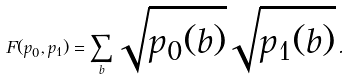Convert formula to latex. <formula><loc_0><loc_0><loc_500><loc_500>F ( p _ { 0 } , p _ { 1 } ) = \sum _ { b } \sqrt { p _ { 0 } ( b ) } \sqrt { p _ { 1 } ( b ) } \, .</formula> 